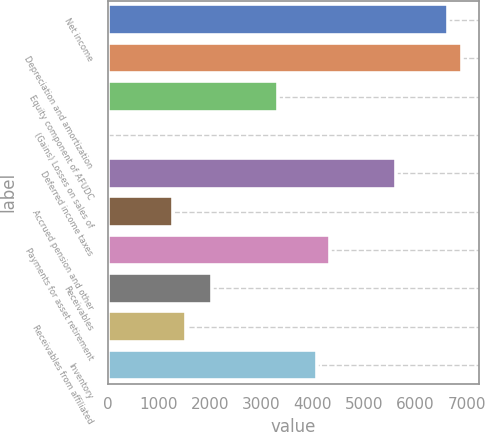Convert chart to OTSL. <chart><loc_0><loc_0><loc_500><loc_500><bar_chart><fcel>Net income<fcel>Depreciation and amortization<fcel>Equity component of AFUDC<fcel>(Gains) Losses on sales of<fcel>Deferred income taxes<fcel>Accrued pension and other<fcel>Payments for asset retirement<fcel>Receivables<fcel>Receivables from affiliated<fcel>Inventory<nl><fcel>6641.4<fcel>6896.8<fcel>3321.2<fcel>1<fcel>5619.8<fcel>1278<fcel>4342.8<fcel>2044.2<fcel>1533.4<fcel>4087.4<nl></chart> 